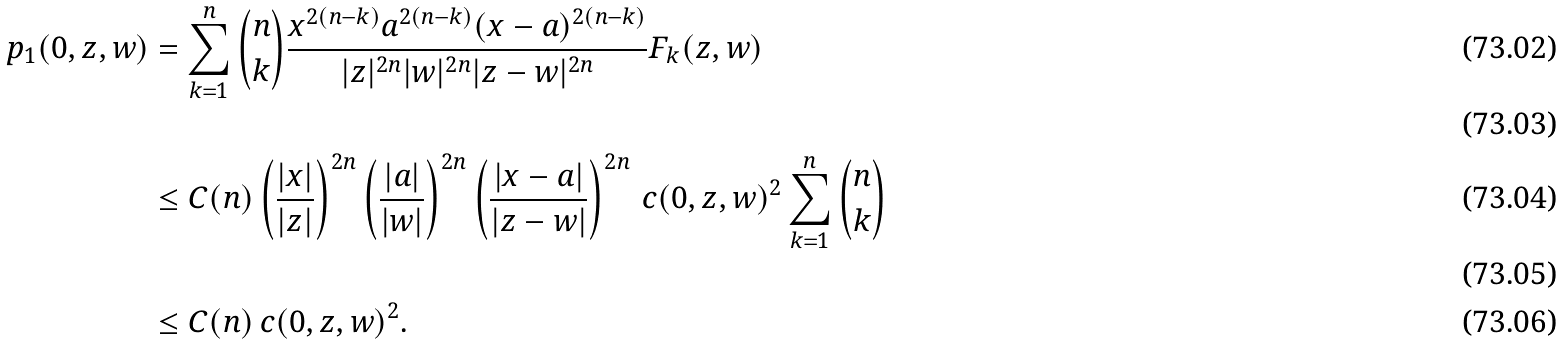Convert formula to latex. <formula><loc_0><loc_0><loc_500><loc_500>p _ { 1 } ( 0 , z , w ) & = \sum _ { k = 1 } ^ { n } \binom { n } { k } \frac { x ^ { 2 ( n - k ) } a ^ { 2 ( n - k ) } ( x - a ) ^ { 2 ( n - k ) } } { | z | ^ { 2 n } | w | ^ { 2 n } | z - w | ^ { 2 n } } F _ { k } ( z , w ) \\ \\ & \leq C ( n ) \left ( \frac { | x | } { | z | } \right ) ^ { 2 n } \left ( \frac { | a | } { | w | } \right ) ^ { 2 n } \left ( \frac { | x - a | } { | z - w | } \right ) ^ { 2 n } \, c ( 0 , z , w ) ^ { 2 } \sum _ { k = 1 } ^ { n } \binom { n } { k } \\ \\ & \leq C ( n ) \, c ( 0 , z , w ) ^ { 2 } .</formula> 